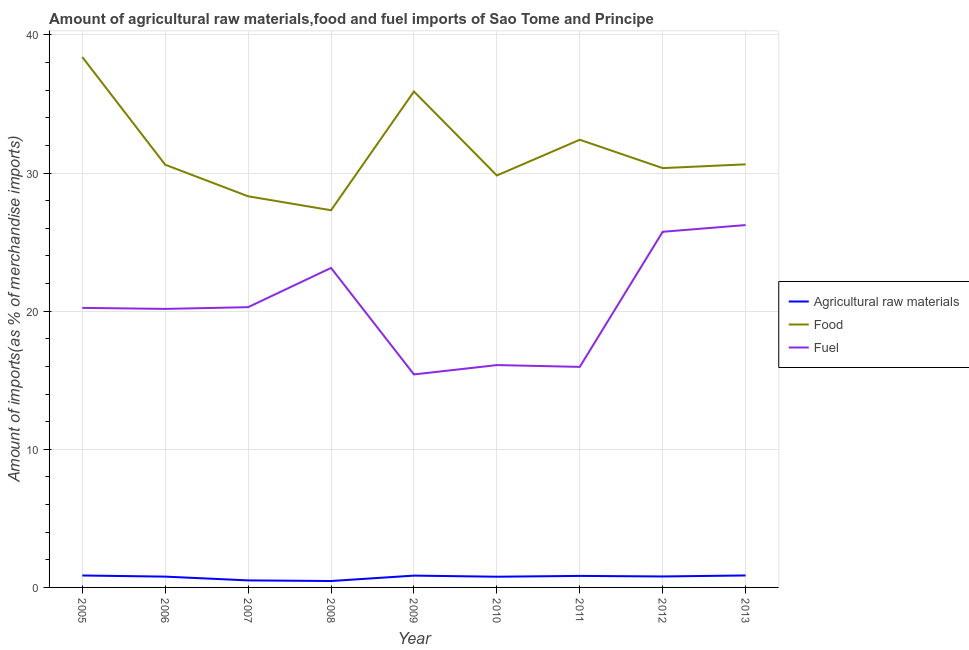Does the line corresponding to percentage of raw materials imports intersect with the line corresponding to percentage of fuel imports?
Your answer should be very brief. No. What is the percentage of raw materials imports in 2011?
Your answer should be compact. 0.83. Across all years, what is the maximum percentage of raw materials imports?
Make the answer very short. 0.87. Across all years, what is the minimum percentage of fuel imports?
Give a very brief answer. 15.42. In which year was the percentage of raw materials imports maximum?
Your answer should be compact. 2013. What is the total percentage of raw materials imports in the graph?
Make the answer very short. 6.74. What is the difference between the percentage of food imports in 2009 and that in 2013?
Provide a short and direct response. 5.28. What is the difference between the percentage of raw materials imports in 2010 and the percentage of food imports in 2011?
Offer a terse response. -31.64. What is the average percentage of fuel imports per year?
Your answer should be compact. 20.37. In the year 2007, what is the difference between the percentage of food imports and percentage of fuel imports?
Ensure brevity in your answer.  8.03. In how many years, is the percentage of raw materials imports greater than 38 %?
Offer a terse response. 0. What is the ratio of the percentage of raw materials imports in 2005 to that in 2009?
Offer a very short reply. 1.01. Is the difference between the percentage of food imports in 2005 and 2013 greater than the difference between the percentage of raw materials imports in 2005 and 2013?
Offer a terse response. Yes. What is the difference between the highest and the second highest percentage of food imports?
Your response must be concise. 2.5. What is the difference between the highest and the lowest percentage of food imports?
Offer a terse response. 11.09. Is the sum of the percentage of food imports in 2010 and 2011 greater than the maximum percentage of raw materials imports across all years?
Your answer should be compact. Yes. Does the percentage of raw materials imports monotonically increase over the years?
Offer a very short reply. No. Is the percentage of raw materials imports strictly less than the percentage of fuel imports over the years?
Your answer should be compact. Yes. Does the graph contain any zero values?
Provide a succinct answer. No. Does the graph contain grids?
Your response must be concise. Yes. How many legend labels are there?
Offer a terse response. 3. What is the title of the graph?
Give a very brief answer. Amount of agricultural raw materials,food and fuel imports of Sao Tome and Principe. What is the label or title of the X-axis?
Give a very brief answer. Year. What is the label or title of the Y-axis?
Your answer should be compact. Amount of imports(as % of merchandise imports). What is the Amount of imports(as % of merchandise imports) of Agricultural raw materials in 2005?
Provide a short and direct response. 0.86. What is the Amount of imports(as % of merchandise imports) of Food in 2005?
Ensure brevity in your answer.  38.4. What is the Amount of imports(as % of merchandise imports) in Fuel in 2005?
Offer a very short reply. 20.24. What is the Amount of imports(as % of merchandise imports) in Agricultural raw materials in 2006?
Provide a short and direct response. 0.78. What is the Amount of imports(as % of merchandise imports) of Food in 2006?
Keep it short and to the point. 30.6. What is the Amount of imports(as % of merchandise imports) in Fuel in 2006?
Your response must be concise. 20.17. What is the Amount of imports(as % of merchandise imports) in Agricultural raw materials in 2007?
Offer a very short reply. 0.51. What is the Amount of imports(as % of merchandise imports) in Food in 2007?
Your response must be concise. 28.32. What is the Amount of imports(as % of merchandise imports) in Fuel in 2007?
Keep it short and to the point. 20.29. What is the Amount of imports(as % of merchandise imports) of Agricultural raw materials in 2008?
Keep it short and to the point. 0.46. What is the Amount of imports(as % of merchandise imports) in Food in 2008?
Ensure brevity in your answer.  27.31. What is the Amount of imports(as % of merchandise imports) of Fuel in 2008?
Your answer should be compact. 23.13. What is the Amount of imports(as % of merchandise imports) in Agricultural raw materials in 2009?
Your answer should be very brief. 0.86. What is the Amount of imports(as % of merchandise imports) of Food in 2009?
Ensure brevity in your answer.  35.91. What is the Amount of imports(as % of merchandise imports) in Fuel in 2009?
Provide a succinct answer. 15.42. What is the Amount of imports(as % of merchandise imports) of Agricultural raw materials in 2010?
Provide a succinct answer. 0.77. What is the Amount of imports(as % of merchandise imports) in Food in 2010?
Provide a succinct answer. 29.83. What is the Amount of imports(as % of merchandise imports) in Fuel in 2010?
Keep it short and to the point. 16.1. What is the Amount of imports(as % of merchandise imports) of Agricultural raw materials in 2011?
Offer a terse response. 0.83. What is the Amount of imports(as % of merchandise imports) of Food in 2011?
Offer a terse response. 32.41. What is the Amount of imports(as % of merchandise imports) in Fuel in 2011?
Make the answer very short. 15.97. What is the Amount of imports(as % of merchandise imports) in Agricultural raw materials in 2012?
Give a very brief answer. 0.79. What is the Amount of imports(as % of merchandise imports) of Food in 2012?
Provide a succinct answer. 30.36. What is the Amount of imports(as % of merchandise imports) in Fuel in 2012?
Ensure brevity in your answer.  25.75. What is the Amount of imports(as % of merchandise imports) of Agricultural raw materials in 2013?
Keep it short and to the point. 0.87. What is the Amount of imports(as % of merchandise imports) of Food in 2013?
Your answer should be compact. 30.63. What is the Amount of imports(as % of merchandise imports) in Fuel in 2013?
Offer a very short reply. 26.24. Across all years, what is the maximum Amount of imports(as % of merchandise imports) in Agricultural raw materials?
Give a very brief answer. 0.87. Across all years, what is the maximum Amount of imports(as % of merchandise imports) in Food?
Offer a terse response. 38.4. Across all years, what is the maximum Amount of imports(as % of merchandise imports) in Fuel?
Your answer should be very brief. 26.24. Across all years, what is the minimum Amount of imports(as % of merchandise imports) in Agricultural raw materials?
Your response must be concise. 0.46. Across all years, what is the minimum Amount of imports(as % of merchandise imports) of Food?
Keep it short and to the point. 27.31. Across all years, what is the minimum Amount of imports(as % of merchandise imports) of Fuel?
Ensure brevity in your answer.  15.42. What is the total Amount of imports(as % of merchandise imports) of Agricultural raw materials in the graph?
Offer a terse response. 6.74. What is the total Amount of imports(as % of merchandise imports) in Food in the graph?
Your answer should be very brief. 283.77. What is the total Amount of imports(as % of merchandise imports) in Fuel in the graph?
Ensure brevity in your answer.  183.3. What is the difference between the Amount of imports(as % of merchandise imports) of Agricultural raw materials in 2005 and that in 2006?
Provide a short and direct response. 0.08. What is the difference between the Amount of imports(as % of merchandise imports) in Food in 2005 and that in 2006?
Keep it short and to the point. 7.8. What is the difference between the Amount of imports(as % of merchandise imports) in Fuel in 2005 and that in 2006?
Offer a terse response. 0.07. What is the difference between the Amount of imports(as % of merchandise imports) of Agricultural raw materials in 2005 and that in 2007?
Provide a short and direct response. 0.36. What is the difference between the Amount of imports(as % of merchandise imports) of Food in 2005 and that in 2007?
Offer a very short reply. 10.08. What is the difference between the Amount of imports(as % of merchandise imports) in Fuel in 2005 and that in 2007?
Provide a short and direct response. -0.05. What is the difference between the Amount of imports(as % of merchandise imports) of Agricultural raw materials in 2005 and that in 2008?
Make the answer very short. 0.4. What is the difference between the Amount of imports(as % of merchandise imports) of Food in 2005 and that in 2008?
Offer a very short reply. 11.09. What is the difference between the Amount of imports(as % of merchandise imports) in Fuel in 2005 and that in 2008?
Provide a short and direct response. -2.89. What is the difference between the Amount of imports(as % of merchandise imports) of Agricultural raw materials in 2005 and that in 2009?
Provide a short and direct response. 0.01. What is the difference between the Amount of imports(as % of merchandise imports) of Food in 2005 and that in 2009?
Offer a very short reply. 2.5. What is the difference between the Amount of imports(as % of merchandise imports) in Fuel in 2005 and that in 2009?
Your answer should be compact. 4.82. What is the difference between the Amount of imports(as % of merchandise imports) in Agricultural raw materials in 2005 and that in 2010?
Keep it short and to the point. 0.09. What is the difference between the Amount of imports(as % of merchandise imports) of Food in 2005 and that in 2010?
Offer a terse response. 8.58. What is the difference between the Amount of imports(as % of merchandise imports) in Fuel in 2005 and that in 2010?
Provide a succinct answer. 4.14. What is the difference between the Amount of imports(as % of merchandise imports) in Agricultural raw materials in 2005 and that in 2011?
Give a very brief answer. 0.03. What is the difference between the Amount of imports(as % of merchandise imports) of Food in 2005 and that in 2011?
Your answer should be compact. 5.99. What is the difference between the Amount of imports(as % of merchandise imports) of Fuel in 2005 and that in 2011?
Offer a very short reply. 4.27. What is the difference between the Amount of imports(as % of merchandise imports) in Agricultural raw materials in 2005 and that in 2012?
Ensure brevity in your answer.  0.07. What is the difference between the Amount of imports(as % of merchandise imports) of Food in 2005 and that in 2012?
Offer a very short reply. 8.04. What is the difference between the Amount of imports(as % of merchandise imports) in Fuel in 2005 and that in 2012?
Your answer should be compact. -5.51. What is the difference between the Amount of imports(as % of merchandise imports) in Agricultural raw materials in 2005 and that in 2013?
Keep it short and to the point. -0. What is the difference between the Amount of imports(as % of merchandise imports) of Food in 2005 and that in 2013?
Keep it short and to the point. 7.77. What is the difference between the Amount of imports(as % of merchandise imports) of Fuel in 2005 and that in 2013?
Your answer should be compact. -6. What is the difference between the Amount of imports(as % of merchandise imports) in Agricultural raw materials in 2006 and that in 2007?
Your answer should be very brief. 0.27. What is the difference between the Amount of imports(as % of merchandise imports) in Food in 2006 and that in 2007?
Your answer should be very brief. 2.29. What is the difference between the Amount of imports(as % of merchandise imports) of Fuel in 2006 and that in 2007?
Keep it short and to the point. -0.12. What is the difference between the Amount of imports(as % of merchandise imports) in Agricultural raw materials in 2006 and that in 2008?
Provide a short and direct response. 0.32. What is the difference between the Amount of imports(as % of merchandise imports) of Food in 2006 and that in 2008?
Give a very brief answer. 3.3. What is the difference between the Amount of imports(as % of merchandise imports) in Fuel in 2006 and that in 2008?
Make the answer very short. -2.97. What is the difference between the Amount of imports(as % of merchandise imports) in Agricultural raw materials in 2006 and that in 2009?
Your response must be concise. -0.07. What is the difference between the Amount of imports(as % of merchandise imports) in Food in 2006 and that in 2009?
Provide a succinct answer. -5.3. What is the difference between the Amount of imports(as % of merchandise imports) in Fuel in 2006 and that in 2009?
Keep it short and to the point. 4.74. What is the difference between the Amount of imports(as % of merchandise imports) in Agricultural raw materials in 2006 and that in 2010?
Your response must be concise. 0.01. What is the difference between the Amount of imports(as % of merchandise imports) of Food in 2006 and that in 2010?
Make the answer very short. 0.78. What is the difference between the Amount of imports(as % of merchandise imports) in Fuel in 2006 and that in 2010?
Make the answer very short. 4.07. What is the difference between the Amount of imports(as % of merchandise imports) in Agricultural raw materials in 2006 and that in 2011?
Offer a terse response. -0.05. What is the difference between the Amount of imports(as % of merchandise imports) in Food in 2006 and that in 2011?
Offer a very short reply. -1.81. What is the difference between the Amount of imports(as % of merchandise imports) of Fuel in 2006 and that in 2011?
Provide a short and direct response. 4.2. What is the difference between the Amount of imports(as % of merchandise imports) in Agricultural raw materials in 2006 and that in 2012?
Ensure brevity in your answer.  -0.01. What is the difference between the Amount of imports(as % of merchandise imports) in Food in 2006 and that in 2012?
Provide a short and direct response. 0.24. What is the difference between the Amount of imports(as % of merchandise imports) of Fuel in 2006 and that in 2012?
Offer a terse response. -5.58. What is the difference between the Amount of imports(as % of merchandise imports) in Agricultural raw materials in 2006 and that in 2013?
Your answer should be compact. -0.08. What is the difference between the Amount of imports(as % of merchandise imports) of Food in 2006 and that in 2013?
Your answer should be very brief. -0.03. What is the difference between the Amount of imports(as % of merchandise imports) in Fuel in 2006 and that in 2013?
Offer a very short reply. -6.07. What is the difference between the Amount of imports(as % of merchandise imports) of Agricultural raw materials in 2007 and that in 2008?
Give a very brief answer. 0.05. What is the difference between the Amount of imports(as % of merchandise imports) of Food in 2007 and that in 2008?
Keep it short and to the point. 1.01. What is the difference between the Amount of imports(as % of merchandise imports) of Fuel in 2007 and that in 2008?
Keep it short and to the point. -2.84. What is the difference between the Amount of imports(as % of merchandise imports) in Agricultural raw materials in 2007 and that in 2009?
Your answer should be very brief. -0.35. What is the difference between the Amount of imports(as % of merchandise imports) of Food in 2007 and that in 2009?
Offer a terse response. -7.59. What is the difference between the Amount of imports(as % of merchandise imports) of Fuel in 2007 and that in 2009?
Give a very brief answer. 4.87. What is the difference between the Amount of imports(as % of merchandise imports) of Agricultural raw materials in 2007 and that in 2010?
Give a very brief answer. -0.27. What is the difference between the Amount of imports(as % of merchandise imports) in Food in 2007 and that in 2010?
Keep it short and to the point. -1.51. What is the difference between the Amount of imports(as % of merchandise imports) of Fuel in 2007 and that in 2010?
Give a very brief answer. 4.19. What is the difference between the Amount of imports(as % of merchandise imports) in Agricultural raw materials in 2007 and that in 2011?
Offer a terse response. -0.32. What is the difference between the Amount of imports(as % of merchandise imports) of Food in 2007 and that in 2011?
Offer a terse response. -4.09. What is the difference between the Amount of imports(as % of merchandise imports) of Fuel in 2007 and that in 2011?
Your answer should be compact. 4.32. What is the difference between the Amount of imports(as % of merchandise imports) in Agricultural raw materials in 2007 and that in 2012?
Your answer should be compact. -0.28. What is the difference between the Amount of imports(as % of merchandise imports) in Food in 2007 and that in 2012?
Make the answer very short. -2.04. What is the difference between the Amount of imports(as % of merchandise imports) of Fuel in 2007 and that in 2012?
Offer a very short reply. -5.46. What is the difference between the Amount of imports(as % of merchandise imports) of Agricultural raw materials in 2007 and that in 2013?
Your response must be concise. -0.36. What is the difference between the Amount of imports(as % of merchandise imports) of Food in 2007 and that in 2013?
Provide a short and direct response. -2.31. What is the difference between the Amount of imports(as % of merchandise imports) of Fuel in 2007 and that in 2013?
Ensure brevity in your answer.  -5.94. What is the difference between the Amount of imports(as % of merchandise imports) of Agricultural raw materials in 2008 and that in 2009?
Keep it short and to the point. -0.39. What is the difference between the Amount of imports(as % of merchandise imports) of Food in 2008 and that in 2009?
Offer a terse response. -8.6. What is the difference between the Amount of imports(as % of merchandise imports) of Fuel in 2008 and that in 2009?
Offer a very short reply. 7.71. What is the difference between the Amount of imports(as % of merchandise imports) of Agricultural raw materials in 2008 and that in 2010?
Offer a very short reply. -0.31. What is the difference between the Amount of imports(as % of merchandise imports) in Food in 2008 and that in 2010?
Provide a short and direct response. -2.52. What is the difference between the Amount of imports(as % of merchandise imports) in Fuel in 2008 and that in 2010?
Keep it short and to the point. 7.03. What is the difference between the Amount of imports(as % of merchandise imports) of Agricultural raw materials in 2008 and that in 2011?
Give a very brief answer. -0.37. What is the difference between the Amount of imports(as % of merchandise imports) of Food in 2008 and that in 2011?
Offer a terse response. -5.1. What is the difference between the Amount of imports(as % of merchandise imports) of Fuel in 2008 and that in 2011?
Offer a very short reply. 7.16. What is the difference between the Amount of imports(as % of merchandise imports) of Agricultural raw materials in 2008 and that in 2012?
Provide a short and direct response. -0.33. What is the difference between the Amount of imports(as % of merchandise imports) of Food in 2008 and that in 2012?
Make the answer very short. -3.05. What is the difference between the Amount of imports(as % of merchandise imports) of Fuel in 2008 and that in 2012?
Your answer should be very brief. -2.62. What is the difference between the Amount of imports(as % of merchandise imports) in Agricultural raw materials in 2008 and that in 2013?
Offer a very short reply. -0.4. What is the difference between the Amount of imports(as % of merchandise imports) of Food in 2008 and that in 2013?
Your answer should be compact. -3.32. What is the difference between the Amount of imports(as % of merchandise imports) of Fuel in 2008 and that in 2013?
Provide a succinct answer. -3.1. What is the difference between the Amount of imports(as % of merchandise imports) in Agricultural raw materials in 2009 and that in 2010?
Make the answer very short. 0.08. What is the difference between the Amount of imports(as % of merchandise imports) in Food in 2009 and that in 2010?
Your answer should be very brief. 6.08. What is the difference between the Amount of imports(as % of merchandise imports) of Fuel in 2009 and that in 2010?
Offer a very short reply. -0.68. What is the difference between the Amount of imports(as % of merchandise imports) in Agricultural raw materials in 2009 and that in 2011?
Ensure brevity in your answer.  0.02. What is the difference between the Amount of imports(as % of merchandise imports) in Food in 2009 and that in 2011?
Provide a succinct answer. 3.49. What is the difference between the Amount of imports(as % of merchandise imports) in Fuel in 2009 and that in 2011?
Keep it short and to the point. -0.55. What is the difference between the Amount of imports(as % of merchandise imports) of Agricultural raw materials in 2009 and that in 2012?
Your answer should be very brief. 0.06. What is the difference between the Amount of imports(as % of merchandise imports) of Food in 2009 and that in 2012?
Your answer should be compact. 5.55. What is the difference between the Amount of imports(as % of merchandise imports) of Fuel in 2009 and that in 2012?
Make the answer very short. -10.33. What is the difference between the Amount of imports(as % of merchandise imports) of Agricultural raw materials in 2009 and that in 2013?
Offer a very short reply. -0.01. What is the difference between the Amount of imports(as % of merchandise imports) in Food in 2009 and that in 2013?
Give a very brief answer. 5.28. What is the difference between the Amount of imports(as % of merchandise imports) in Fuel in 2009 and that in 2013?
Ensure brevity in your answer.  -10.81. What is the difference between the Amount of imports(as % of merchandise imports) in Agricultural raw materials in 2010 and that in 2011?
Give a very brief answer. -0.06. What is the difference between the Amount of imports(as % of merchandise imports) of Food in 2010 and that in 2011?
Your response must be concise. -2.59. What is the difference between the Amount of imports(as % of merchandise imports) of Fuel in 2010 and that in 2011?
Your response must be concise. 0.13. What is the difference between the Amount of imports(as % of merchandise imports) of Agricultural raw materials in 2010 and that in 2012?
Provide a short and direct response. -0.02. What is the difference between the Amount of imports(as % of merchandise imports) of Food in 2010 and that in 2012?
Offer a terse response. -0.53. What is the difference between the Amount of imports(as % of merchandise imports) of Fuel in 2010 and that in 2012?
Your answer should be very brief. -9.65. What is the difference between the Amount of imports(as % of merchandise imports) of Agricultural raw materials in 2010 and that in 2013?
Make the answer very short. -0.09. What is the difference between the Amount of imports(as % of merchandise imports) of Food in 2010 and that in 2013?
Make the answer very short. -0.81. What is the difference between the Amount of imports(as % of merchandise imports) of Fuel in 2010 and that in 2013?
Your answer should be very brief. -10.14. What is the difference between the Amount of imports(as % of merchandise imports) of Agricultural raw materials in 2011 and that in 2012?
Offer a terse response. 0.04. What is the difference between the Amount of imports(as % of merchandise imports) in Food in 2011 and that in 2012?
Provide a short and direct response. 2.05. What is the difference between the Amount of imports(as % of merchandise imports) of Fuel in 2011 and that in 2012?
Your answer should be compact. -9.78. What is the difference between the Amount of imports(as % of merchandise imports) of Agricultural raw materials in 2011 and that in 2013?
Give a very brief answer. -0.03. What is the difference between the Amount of imports(as % of merchandise imports) in Food in 2011 and that in 2013?
Keep it short and to the point. 1.78. What is the difference between the Amount of imports(as % of merchandise imports) in Fuel in 2011 and that in 2013?
Your answer should be compact. -10.27. What is the difference between the Amount of imports(as % of merchandise imports) in Agricultural raw materials in 2012 and that in 2013?
Your response must be concise. -0.07. What is the difference between the Amount of imports(as % of merchandise imports) of Food in 2012 and that in 2013?
Provide a succinct answer. -0.27. What is the difference between the Amount of imports(as % of merchandise imports) in Fuel in 2012 and that in 2013?
Provide a succinct answer. -0.49. What is the difference between the Amount of imports(as % of merchandise imports) in Agricultural raw materials in 2005 and the Amount of imports(as % of merchandise imports) in Food in 2006?
Your response must be concise. -29.74. What is the difference between the Amount of imports(as % of merchandise imports) in Agricultural raw materials in 2005 and the Amount of imports(as % of merchandise imports) in Fuel in 2006?
Provide a succinct answer. -19.3. What is the difference between the Amount of imports(as % of merchandise imports) in Food in 2005 and the Amount of imports(as % of merchandise imports) in Fuel in 2006?
Provide a succinct answer. 18.24. What is the difference between the Amount of imports(as % of merchandise imports) of Agricultural raw materials in 2005 and the Amount of imports(as % of merchandise imports) of Food in 2007?
Your response must be concise. -27.45. What is the difference between the Amount of imports(as % of merchandise imports) of Agricultural raw materials in 2005 and the Amount of imports(as % of merchandise imports) of Fuel in 2007?
Give a very brief answer. -19.43. What is the difference between the Amount of imports(as % of merchandise imports) of Food in 2005 and the Amount of imports(as % of merchandise imports) of Fuel in 2007?
Offer a terse response. 18.11. What is the difference between the Amount of imports(as % of merchandise imports) in Agricultural raw materials in 2005 and the Amount of imports(as % of merchandise imports) in Food in 2008?
Keep it short and to the point. -26.44. What is the difference between the Amount of imports(as % of merchandise imports) in Agricultural raw materials in 2005 and the Amount of imports(as % of merchandise imports) in Fuel in 2008?
Your response must be concise. -22.27. What is the difference between the Amount of imports(as % of merchandise imports) of Food in 2005 and the Amount of imports(as % of merchandise imports) of Fuel in 2008?
Keep it short and to the point. 15.27. What is the difference between the Amount of imports(as % of merchandise imports) of Agricultural raw materials in 2005 and the Amount of imports(as % of merchandise imports) of Food in 2009?
Give a very brief answer. -35.04. What is the difference between the Amount of imports(as % of merchandise imports) in Agricultural raw materials in 2005 and the Amount of imports(as % of merchandise imports) in Fuel in 2009?
Provide a succinct answer. -14.56. What is the difference between the Amount of imports(as % of merchandise imports) of Food in 2005 and the Amount of imports(as % of merchandise imports) of Fuel in 2009?
Give a very brief answer. 22.98. What is the difference between the Amount of imports(as % of merchandise imports) in Agricultural raw materials in 2005 and the Amount of imports(as % of merchandise imports) in Food in 2010?
Your response must be concise. -28.96. What is the difference between the Amount of imports(as % of merchandise imports) in Agricultural raw materials in 2005 and the Amount of imports(as % of merchandise imports) in Fuel in 2010?
Give a very brief answer. -15.23. What is the difference between the Amount of imports(as % of merchandise imports) in Food in 2005 and the Amount of imports(as % of merchandise imports) in Fuel in 2010?
Keep it short and to the point. 22.3. What is the difference between the Amount of imports(as % of merchandise imports) in Agricultural raw materials in 2005 and the Amount of imports(as % of merchandise imports) in Food in 2011?
Your answer should be compact. -31.55. What is the difference between the Amount of imports(as % of merchandise imports) of Agricultural raw materials in 2005 and the Amount of imports(as % of merchandise imports) of Fuel in 2011?
Provide a succinct answer. -15.1. What is the difference between the Amount of imports(as % of merchandise imports) in Food in 2005 and the Amount of imports(as % of merchandise imports) in Fuel in 2011?
Make the answer very short. 22.43. What is the difference between the Amount of imports(as % of merchandise imports) in Agricultural raw materials in 2005 and the Amount of imports(as % of merchandise imports) in Food in 2012?
Your response must be concise. -29.5. What is the difference between the Amount of imports(as % of merchandise imports) in Agricultural raw materials in 2005 and the Amount of imports(as % of merchandise imports) in Fuel in 2012?
Make the answer very short. -24.88. What is the difference between the Amount of imports(as % of merchandise imports) of Food in 2005 and the Amount of imports(as % of merchandise imports) of Fuel in 2012?
Your answer should be very brief. 12.65. What is the difference between the Amount of imports(as % of merchandise imports) in Agricultural raw materials in 2005 and the Amount of imports(as % of merchandise imports) in Food in 2013?
Provide a succinct answer. -29.77. What is the difference between the Amount of imports(as % of merchandise imports) in Agricultural raw materials in 2005 and the Amount of imports(as % of merchandise imports) in Fuel in 2013?
Ensure brevity in your answer.  -25.37. What is the difference between the Amount of imports(as % of merchandise imports) of Food in 2005 and the Amount of imports(as % of merchandise imports) of Fuel in 2013?
Ensure brevity in your answer.  12.17. What is the difference between the Amount of imports(as % of merchandise imports) of Agricultural raw materials in 2006 and the Amount of imports(as % of merchandise imports) of Food in 2007?
Your answer should be very brief. -27.54. What is the difference between the Amount of imports(as % of merchandise imports) in Agricultural raw materials in 2006 and the Amount of imports(as % of merchandise imports) in Fuel in 2007?
Ensure brevity in your answer.  -19.51. What is the difference between the Amount of imports(as % of merchandise imports) in Food in 2006 and the Amount of imports(as % of merchandise imports) in Fuel in 2007?
Offer a terse response. 10.31. What is the difference between the Amount of imports(as % of merchandise imports) in Agricultural raw materials in 2006 and the Amount of imports(as % of merchandise imports) in Food in 2008?
Offer a very short reply. -26.53. What is the difference between the Amount of imports(as % of merchandise imports) of Agricultural raw materials in 2006 and the Amount of imports(as % of merchandise imports) of Fuel in 2008?
Your answer should be very brief. -22.35. What is the difference between the Amount of imports(as % of merchandise imports) of Food in 2006 and the Amount of imports(as % of merchandise imports) of Fuel in 2008?
Offer a terse response. 7.47. What is the difference between the Amount of imports(as % of merchandise imports) of Agricultural raw materials in 2006 and the Amount of imports(as % of merchandise imports) of Food in 2009?
Provide a short and direct response. -35.13. What is the difference between the Amount of imports(as % of merchandise imports) in Agricultural raw materials in 2006 and the Amount of imports(as % of merchandise imports) in Fuel in 2009?
Give a very brief answer. -14.64. What is the difference between the Amount of imports(as % of merchandise imports) of Food in 2006 and the Amount of imports(as % of merchandise imports) of Fuel in 2009?
Your answer should be compact. 15.18. What is the difference between the Amount of imports(as % of merchandise imports) in Agricultural raw materials in 2006 and the Amount of imports(as % of merchandise imports) in Food in 2010?
Offer a very short reply. -29.04. What is the difference between the Amount of imports(as % of merchandise imports) in Agricultural raw materials in 2006 and the Amount of imports(as % of merchandise imports) in Fuel in 2010?
Your answer should be very brief. -15.32. What is the difference between the Amount of imports(as % of merchandise imports) of Food in 2006 and the Amount of imports(as % of merchandise imports) of Fuel in 2010?
Provide a succinct answer. 14.51. What is the difference between the Amount of imports(as % of merchandise imports) of Agricultural raw materials in 2006 and the Amount of imports(as % of merchandise imports) of Food in 2011?
Give a very brief answer. -31.63. What is the difference between the Amount of imports(as % of merchandise imports) in Agricultural raw materials in 2006 and the Amount of imports(as % of merchandise imports) in Fuel in 2011?
Offer a very short reply. -15.19. What is the difference between the Amount of imports(as % of merchandise imports) of Food in 2006 and the Amount of imports(as % of merchandise imports) of Fuel in 2011?
Your response must be concise. 14.64. What is the difference between the Amount of imports(as % of merchandise imports) in Agricultural raw materials in 2006 and the Amount of imports(as % of merchandise imports) in Food in 2012?
Provide a succinct answer. -29.58. What is the difference between the Amount of imports(as % of merchandise imports) of Agricultural raw materials in 2006 and the Amount of imports(as % of merchandise imports) of Fuel in 2012?
Your response must be concise. -24.97. What is the difference between the Amount of imports(as % of merchandise imports) in Food in 2006 and the Amount of imports(as % of merchandise imports) in Fuel in 2012?
Ensure brevity in your answer.  4.86. What is the difference between the Amount of imports(as % of merchandise imports) in Agricultural raw materials in 2006 and the Amount of imports(as % of merchandise imports) in Food in 2013?
Provide a succinct answer. -29.85. What is the difference between the Amount of imports(as % of merchandise imports) in Agricultural raw materials in 2006 and the Amount of imports(as % of merchandise imports) in Fuel in 2013?
Ensure brevity in your answer.  -25.45. What is the difference between the Amount of imports(as % of merchandise imports) in Food in 2006 and the Amount of imports(as % of merchandise imports) in Fuel in 2013?
Your answer should be compact. 4.37. What is the difference between the Amount of imports(as % of merchandise imports) in Agricultural raw materials in 2007 and the Amount of imports(as % of merchandise imports) in Food in 2008?
Keep it short and to the point. -26.8. What is the difference between the Amount of imports(as % of merchandise imports) of Agricultural raw materials in 2007 and the Amount of imports(as % of merchandise imports) of Fuel in 2008?
Provide a short and direct response. -22.62. What is the difference between the Amount of imports(as % of merchandise imports) in Food in 2007 and the Amount of imports(as % of merchandise imports) in Fuel in 2008?
Keep it short and to the point. 5.19. What is the difference between the Amount of imports(as % of merchandise imports) of Agricultural raw materials in 2007 and the Amount of imports(as % of merchandise imports) of Food in 2009?
Keep it short and to the point. -35.4. What is the difference between the Amount of imports(as % of merchandise imports) in Agricultural raw materials in 2007 and the Amount of imports(as % of merchandise imports) in Fuel in 2009?
Offer a very short reply. -14.91. What is the difference between the Amount of imports(as % of merchandise imports) of Food in 2007 and the Amount of imports(as % of merchandise imports) of Fuel in 2009?
Offer a terse response. 12.9. What is the difference between the Amount of imports(as % of merchandise imports) of Agricultural raw materials in 2007 and the Amount of imports(as % of merchandise imports) of Food in 2010?
Provide a succinct answer. -29.32. What is the difference between the Amount of imports(as % of merchandise imports) in Agricultural raw materials in 2007 and the Amount of imports(as % of merchandise imports) in Fuel in 2010?
Make the answer very short. -15.59. What is the difference between the Amount of imports(as % of merchandise imports) of Food in 2007 and the Amount of imports(as % of merchandise imports) of Fuel in 2010?
Make the answer very short. 12.22. What is the difference between the Amount of imports(as % of merchandise imports) in Agricultural raw materials in 2007 and the Amount of imports(as % of merchandise imports) in Food in 2011?
Your response must be concise. -31.9. What is the difference between the Amount of imports(as % of merchandise imports) in Agricultural raw materials in 2007 and the Amount of imports(as % of merchandise imports) in Fuel in 2011?
Ensure brevity in your answer.  -15.46. What is the difference between the Amount of imports(as % of merchandise imports) of Food in 2007 and the Amount of imports(as % of merchandise imports) of Fuel in 2011?
Make the answer very short. 12.35. What is the difference between the Amount of imports(as % of merchandise imports) in Agricultural raw materials in 2007 and the Amount of imports(as % of merchandise imports) in Food in 2012?
Make the answer very short. -29.85. What is the difference between the Amount of imports(as % of merchandise imports) of Agricultural raw materials in 2007 and the Amount of imports(as % of merchandise imports) of Fuel in 2012?
Your response must be concise. -25.24. What is the difference between the Amount of imports(as % of merchandise imports) in Food in 2007 and the Amount of imports(as % of merchandise imports) in Fuel in 2012?
Your answer should be very brief. 2.57. What is the difference between the Amount of imports(as % of merchandise imports) in Agricultural raw materials in 2007 and the Amount of imports(as % of merchandise imports) in Food in 2013?
Your answer should be very brief. -30.12. What is the difference between the Amount of imports(as % of merchandise imports) of Agricultural raw materials in 2007 and the Amount of imports(as % of merchandise imports) of Fuel in 2013?
Make the answer very short. -25.73. What is the difference between the Amount of imports(as % of merchandise imports) of Food in 2007 and the Amount of imports(as % of merchandise imports) of Fuel in 2013?
Make the answer very short. 2.08. What is the difference between the Amount of imports(as % of merchandise imports) in Agricultural raw materials in 2008 and the Amount of imports(as % of merchandise imports) in Food in 2009?
Ensure brevity in your answer.  -35.44. What is the difference between the Amount of imports(as % of merchandise imports) of Agricultural raw materials in 2008 and the Amount of imports(as % of merchandise imports) of Fuel in 2009?
Your answer should be compact. -14.96. What is the difference between the Amount of imports(as % of merchandise imports) of Food in 2008 and the Amount of imports(as % of merchandise imports) of Fuel in 2009?
Your answer should be compact. 11.89. What is the difference between the Amount of imports(as % of merchandise imports) in Agricultural raw materials in 2008 and the Amount of imports(as % of merchandise imports) in Food in 2010?
Ensure brevity in your answer.  -29.36. What is the difference between the Amount of imports(as % of merchandise imports) of Agricultural raw materials in 2008 and the Amount of imports(as % of merchandise imports) of Fuel in 2010?
Your response must be concise. -15.63. What is the difference between the Amount of imports(as % of merchandise imports) of Food in 2008 and the Amount of imports(as % of merchandise imports) of Fuel in 2010?
Make the answer very short. 11.21. What is the difference between the Amount of imports(as % of merchandise imports) in Agricultural raw materials in 2008 and the Amount of imports(as % of merchandise imports) in Food in 2011?
Your answer should be compact. -31.95. What is the difference between the Amount of imports(as % of merchandise imports) of Agricultural raw materials in 2008 and the Amount of imports(as % of merchandise imports) of Fuel in 2011?
Make the answer very short. -15.5. What is the difference between the Amount of imports(as % of merchandise imports) of Food in 2008 and the Amount of imports(as % of merchandise imports) of Fuel in 2011?
Provide a succinct answer. 11.34. What is the difference between the Amount of imports(as % of merchandise imports) of Agricultural raw materials in 2008 and the Amount of imports(as % of merchandise imports) of Food in 2012?
Offer a very short reply. -29.9. What is the difference between the Amount of imports(as % of merchandise imports) in Agricultural raw materials in 2008 and the Amount of imports(as % of merchandise imports) in Fuel in 2012?
Provide a short and direct response. -25.29. What is the difference between the Amount of imports(as % of merchandise imports) in Food in 2008 and the Amount of imports(as % of merchandise imports) in Fuel in 2012?
Give a very brief answer. 1.56. What is the difference between the Amount of imports(as % of merchandise imports) of Agricultural raw materials in 2008 and the Amount of imports(as % of merchandise imports) of Food in 2013?
Your response must be concise. -30.17. What is the difference between the Amount of imports(as % of merchandise imports) in Agricultural raw materials in 2008 and the Amount of imports(as % of merchandise imports) in Fuel in 2013?
Your response must be concise. -25.77. What is the difference between the Amount of imports(as % of merchandise imports) of Food in 2008 and the Amount of imports(as % of merchandise imports) of Fuel in 2013?
Make the answer very short. 1.07. What is the difference between the Amount of imports(as % of merchandise imports) of Agricultural raw materials in 2009 and the Amount of imports(as % of merchandise imports) of Food in 2010?
Keep it short and to the point. -28.97. What is the difference between the Amount of imports(as % of merchandise imports) in Agricultural raw materials in 2009 and the Amount of imports(as % of merchandise imports) in Fuel in 2010?
Your answer should be compact. -15.24. What is the difference between the Amount of imports(as % of merchandise imports) in Food in 2009 and the Amount of imports(as % of merchandise imports) in Fuel in 2010?
Provide a succinct answer. 19.81. What is the difference between the Amount of imports(as % of merchandise imports) in Agricultural raw materials in 2009 and the Amount of imports(as % of merchandise imports) in Food in 2011?
Ensure brevity in your answer.  -31.56. What is the difference between the Amount of imports(as % of merchandise imports) of Agricultural raw materials in 2009 and the Amount of imports(as % of merchandise imports) of Fuel in 2011?
Make the answer very short. -15.11. What is the difference between the Amount of imports(as % of merchandise imports) in Food in 2009 and the Amount of imports(as % of merchandise imports) in Fuel in 2011?
Give a very brief answer. 19.94. What is the difference between the Amount of imports(as % of merchandise imports) in Agricultural raw materials in 2009 and the Amount of imports(as % of merchandise imports) in Food in 2012?
Keep it short and to the point. -29.5. What is the difference between the Amount of imports(as % of merchandise imports) of Agricultural raw materials in 2009 and the Amount of imports(as % of merchandise imports) of Fuel in 2012?
Your answer should be very brief. -24.89. What is the difference between the Amount of imports(as % of merchandise imports) in Food in 2009 and the Amount of imports(as % of merchandise imports) in Fuel in 2012?
Your answer should be very brief. 10.16. What is the difference between the Amount of imports(as % of merchandise imports) in Agricultural raw materials in 2009 and the Amount of imports(as % of merchandise imports) in Food in 2013?
Ensure brevity in your answer.  -29.78. What is the difference between the Amount of imports(as % of merchandise imports) of Agricultural raw materials in 2009 and the Amount of imports(as % of merchandise imports) of Fuel in 2013?
Your answer should be very brief. -25.38. What is the difference between the Amount of imports(as % of merchandise imports) in Food in 2009 and the Amount of imports(as % of merchandise imports) in Fuel in 2013?
Your answer should be very brief. 9.67. What is the difference between the Amount of imports(as % of merchandise imports) in Agricultural raw materials in 2010 and the Amount of imports(as % of merchandise imports) in Food in 2011?
Make the answer very short. -31.64. What is the difference between the Amount of imports(as % of merchandise imports) of Agricultural raw materials in 2010 and the Amount of imports(as % of merchandise imports) of Fuel in 2011?
Offer a terse response. -15.19. What is the difference between the Amount of imports(as % of merchandise imports) in Food in 2010 and the Amount of imports(as % of merchandise imports) in Fuel in 2011?
Your answer should be very brief. 13.86. What is the difference between the Amount of imports(as % of merchandise imports) in Agricultural raw materials in 2010 and the Amount of imports(as % of merchandise imports) in Food in 2012?
Make the answer very short. -29.59. What is the difference between the Amount of imports(as % of merchandise imports) of Agricultural raw materials in 2010 and the Amount of imports(as % of merchandise imports) of Fuel in 2012?
Your response must be concise. -24.97. What is the difference between the Amount of imports(as % of merchandise imports) in Food in 2010 and the Amount of imports(as % of merchandise imports) in Fuel in 2012?
Offer a terse response. 4.08. What is the difference between the Amount of imports(as % of merchandise imports) in Agricultural raw materials in 2010 and the Amount of imports(as % of merchandise imports) in Food in 2013?
Provide a short and direct response. -29.86. What is the difference between the Amount of imports(as % of merchandise imports) in Agricultural raw materials in 2010 and the Amount of imports(as % of merchandise imports) in Fuel in 2013?
Provide a short and direct response. -25.46. What is the difference between the Amount of imports(as % of merchandise imports) in Food in 2010 and the Amount of imports(as % of merchandise imports) in Fuel in 2013?
Your response must be concise. 3.59. What is the difference between the Amount of imports(as % of merchandise imports) of Agricultural raw materials in 2011 and the Amount of imports(as % of merchandise imports) of Food in 2012?
Give a very brief answer. -29.53. What is the difference between the Amount of imports(as % of merchandise imports) of Agricultural raw materials in 2011 and the Amount of imports(as % of merchandise imports) of Fuel in 2012?
Your answer should be very brief. -24.92. What is the difference between the Amount of imports(as % of merchandise imports) of Food in 2011 and the Amount of imports(as % of merchandise imports) of Fuel in 2012?
Provide a short and direct response. 6.66. What is the difference between the Amount of imports(as % of merchandise imports) of Agricultural raw materials in 2011 and the Amount of imports(as % of merchandise imports) of Food in 2013?
Make the answer very short. -29.8. What is the difference between the Amount of imports(as % of merchandise imports) in Agricultural raw materials in 2011 and the Amount of imports(as % of merchandise imports) in Fuel in 2013?
Your answer should be compact. -25.4. What is the difference between the Amount of imports(as % of merchandise imports) in Food in 2011 and the Amount of imports(as % of merchandise imports) in Fuel in 2013?
Provide a succinct answer. 6.18. What is the difference between the Amount of imports(as % of merchandise imports) of Agricultural raw materials in 2012 and the Amount of imports(as % of merchandise imports) of Food in 2013?
Make the answer very short. -29.84. What is the difference between the Amount of imports(as % of merchandise imports) in Agricultural raw materials in 2012 and the Amount of imports(as % of merchandise imports) in Fuel in 2013?
Give a very brief answer. -25.44. What is the difference between the Amount of imports(as % of merchandise imports) of Food in 2012 and the Amount of imports(as % of merchandise imports) of Fuel in 2013?
Make the answer very short. 4.12. What is the average Amount of imports(as % of merchandise imports) of Agricultural raw materials per year?
Provide a succinct answer. 0.75. What is the average Amount of imports(as % of merchandise imports) in Food per year?
Offer a very short reply. 31.53. What is the average Amount of imports(as % of merchandise imports) in Fuel per year?
Make the answer very short. 20.37. In the year 2005, what is the difference between the Amount of imports(as % of merchandise imports) in Agricultural raw materials and Amount of imports(as % of merchandise imports) in Food?
Ensure brevity in your answer.  -37.54. In the year 2005, what is the difference between the Amount of imports(as % of merchandise imports) of Agricultural raw materials and Amount of imports(as % of merchandise imports) of Fuel?
Ensure brevity in your answer.  -19.38. In the year 2005, what is the difference between the Amount of imports(as % of merchandise imports) of Food and Amount of imports(as % of merchandise imports) of Fuel?
Make the answer very short. 18.16. In the year 2006, what is the difference between the Amount of imports(as % of merchandise imports) in Agricultural raw materials and Amount of imports(as % of merchandise imports) in Food?
Make the answer very short. -29.82. In the year 2006, what is the difference between the Amount of imports(as % of merchandise imports) in Agricultural raw materials and Amount of imports(as % of merchandise imports) in Fuel?
Give a very brief answer. -19.38. In the year 2006, what is the difference between the Amount of imports(as % of merchandise imports) in Food and Amount of imports(as % of merchandise imports) in Fuel?
Your response must be concise. 10.44. In the year 2007, what is the difference between the Amount of imports(as % of merchandise imports) of Agricultural raw materials and Amount of imports(as % of merchandise imports) of Food?
Ensure brevity in your answer.  -27.81. In the year 2007, what is the difference between the Amount of imports(as % of merchandise imports) of Agricultural raw materials and Amount of imports(as % of merchandise imports) of Fuel?
Provide a short and direct response. -19.78. In the year 2007, what is the difference between the Amount of imports(as % of merchandise imports) of Food and Amount of imports(as % of merchandise imports) of Fuel?
Make the answer very short. 8.03. In the year 2008, what is the difference between the Amount of imports(as % of merchandise imports) in Agricultural raw materials and Amount of imports(as % of merchandise imports) in Food?
Offer a very short reply. -26.84. In the year 2008, what is the difference between the Amount of imports(as % of merchandise imports) of Agricultural raw materials and Amount of imports(as % of merchandise imports) of Fuel?
Your response must be concise. -22.67. In the year 2008, what is the difference between the Amount of imports(as % of merchandise imports) of Food and Amount of imports(as % of merchandise imports) of Fuel?
Provide a short and direct response. 4.18. In the year 2009, what is the difference between the Amount of imports(as % of merchandise imports) in Agricultural raw materials and Amount of imports(as % of merchandise imports) in Food?
Your answer should be compact. -35.05. In the year 2009, what is the difference between the Amount of imports(as % of merchandise imports) in Agricultural raw materials and Amount of imports(as % of merchandise imports) in Fuel?
Keep it short and to the point. -14.57. In the year 2009, what is the difference between the Amount of imports(as % of merchandise imports) in Food and Amount of imports(as % of merchandise imports) in Fuel?
Ensure brevity in your answer.  20.49. In the year 2010, what is the difference between the Amount of imports(as % of merchandise imports) in Agricultural raw materials and Amount of imports(as % of merchandise imports) in Food?
Keep it short and to the point. -29.05. In the year 2010, what is the difference between the Amount of imports(as % of merchandise imports) in Agricultural raw materials and Amount of imports(as % of merchandise imports) in Fuel?
Offer a terse response. -15.32. In the year 2010, what is the difference between the Amount of imports(as % of merchandise imports) of Food and Amount of imports(as % of merchandise imports) of Fuel?
Offer a very short reply. 13.73. In the year 2011, what is the difference between the Amount of imports(as % of merchandise imports) in Agricultural raw materials and Amount of imports(as % of merchandise imports) in Food?
Provide a short and direct response. -31.58. In the year 2011, what is the difference between the Amount of imports(as % of merchandise imports) of Agricultural raw materials and Amount of imports(as % of merchandise imports) of Fuel?
Ensure brevity in your answer.  -15.13. In the year 2011, what is the difference between the Amount of imports(as % of merchandise imports) of Food and Amount of imports(as % of merchandise imports) of Fuel?
Your answer should be compact. 16.44. In the year 2012, what is the difference between the Amount of imports(as % of merchandise imports) in Agricultural raw materials and Amount of imports(as % of merchandise imports) in Food?
Your answer should be very brief. -29.57. In the year 2012, what is the difference between the Amount of imports(as % of merchandise imports) in Agricultural raw materials and Amount of imports(as % of merchandise imports) in Fuel?
Keep it short and to the point. -24.96. In the year 2012, what is the difference between the Amount of imports(as % of merchandise imports) in Food and Amount of imports(as % of merchandise imports) in Fuel?
Provide a short and direct response. 4.61. In the year 2013, what is the difference between the Amount of imports(as % of merchandise imports) in Agricultural raw materials and Amount of imports(as % of merchandise imports) in Food?
Your response must be concise. -29.77. In the year 2013, what is the difference between the Amount of imports(as % of merchandise imports) in Agricultural raw materials and Amount of imports(as % of merchandise imports) in Fuel?
Keep it short and to the point. -25.37. In the year 2013, what is the difference between the Amount of imports(as % of merchandise imports) in Food and Amount of imports(as % of merchandise imports) in Fuel?
Your response must be concise. 4.4. What is the ratio of the Amount of imports(as % of merchandise imports) of Agricultural raw materials in 2005 to that in 2006?
Your answer should be compact. 1.11. What is the ratio of the Amount of imports(as % of merchandise imports) in Food in 2005 to that in 2006?
Make the answer very short. 1.25. What is the ratio of the Amount of imports(as % of merchandise imports) in Fuel in 2005 to that in 2006?
Your answer should be compact. 1. What is the ratio of the Amount of imports(as % of merchandise imports) of Agricultural raw materials in 2005 to that in 2007?
Keep it short and to the point. 1.7. What is the ratio of the Amount of imports(as % of merchandise imports) of Food in 2005 to that in 2007?
Your response must be concise. 1.36. What is the ratio of the Amount of imports(as % of merchandise imports) of Fuel in 2005 to that in 2007?
Make the answer very short. 1. What is the ratio of the Amount of imports(as % of merchandise imports) in Agricultural raw materials in 2005 to that in 2008?
Provide a short and direct response. 1.86. What is the ratio of the Amount of imports(as % of merchandise imports) of Food in 2005 to that in 2008?
Provide a short and direct response. 1.41. What is the ratio of the Amount of imports(as % of merchandise imports) in Agricultural raw materials in 2005 to that in 2009?
Your response must be concise. 1.01. What is the ratio of the Amount of imports(as % of merchandise imports) in Food in 2005 to that in 2009?
Offer a terse response. 1.07. What is the ratio of the Amount of imports(as % of merchandise imports) in Fuel in 2005 to that in 2009?
Offer a terse response. 1.31. What is the ratio of the Amount of imports(as % of merchandise imports) in Agricultural raw materials in 2005 to that in 2010?
Make the answer very short. 1.12. What is the ratio of the Amount of imports(as % of merchandise imports) in Food in 2005 to that in 2010?
Provide a short and direct response. 1.29. What is the ratio of the Amount of imports(as % of merchandise imports) of Fuel in 2005 to that in 2010?
Give a very brief answer. 1.26. What is the ratio of the Amount of imports(as % of merchandise imports) in Agricultural raw materials in 2005 to that in 2011?
Make the answer very short. 1.04. What is the ratio of the Amount of imports(as % of merchandise imports) in Food in 2005 to that in 2011?
Ensure brevity in your answer.  1.18. What is the ratio of the Amount of imports(as % of merchandise imports) in Fuel in 2005 to that in 2011?
Ensure brevity in your answer.  1.27. What is the ratio of the Amount of imports(as % of merchandise imports) of Agricultural raw materials in 2005 to that in 2012?
Your answer should be very brief. 1.09. What is the ratio of the Amount of imports(as % of merchandise imports) of Food in 2005 to that in 2012?
Make the answer very short. 1.26. What is the ratio of the Amount of imports(as % of merchandise imports) in Fuel in 2005 to that in 2012?
Provide a short and direct response. 0.79. What is the ratio of the Amount of imports(as % of merchandise imports) in Agricultural raw materials in 2005 to that in 2013?
Ensure brevity in your answer.  1. What is the ratio of the Amount of imports(as % of merchandise imports) in Food in 2005 to that in 2013?
Offer a terse response. 1.25. What is the ratio of the Amount of imports(as % of merchandise imports) of Fuel in 2005 to that in 2013?
Make the answer very short. 0.77. What is the ratio of the Amount of imports(as % of merchandise imports) of Agricultural raw materials in 2006 to that in 2007?
Ensure brevity in your answer.  1.53. What is the ratio of the Amount of imports(as % of merchandise imports) in Food in 2006 to that in 2007?
Your answer should be very brief. 1.08. What is the ratio of the Amount of imports(as % of merchandise imports) of Fuel in 2006 to that in 2007?
Give a very brief answer. 0.99. What is the ratio of the Amount of imports(as % of merchandise imports) in Agricultural raw materials in 2006 to that in 2008?
Ensure brevity in your answer.  1.69. What is the ratio of the Amount of imports(as % of merchandise imports) of Food in 2006 to that in 2008?
Offer a very short reply. 1.12. What is the ratio of the Amount of imports(as % of merchandise imports) in Fuel in 2006 to that in 2008?
Ensure brevity in your answer.  0.87. What is the ratio of the Amount of imports(as % of merchandise imports) in Agricultural raw materials in 2006 to that in 2009?
Your answer should be very brief. 0.91. What is the ratio of the Amount of imports(as % of merchandise imports) in Food in 2006 to that in 2009?
Ensure brevity in your answer.  0.85. What is the ratio of the Amount of imports(as % of merchandise imports) in Fuel in 2006 to that in 2009?
Provide a short and direct response. 1.31. What is the ratio of the Amount of imports(as % of merchandise imports) in Agricultural raw materials in 2006 to that in 2010?
Make the answer very short. 1.01. What is the ratio of the Amount of imports(as % of merchandise imports) in Food in 2006 to that in 2010?
Give a very brief answer. 1.03. What is the ratio of the Amount of imports(as % of merchandise imports) in Fuel in 2006 to that in 2010?
Offer a terse response. 1.25. What is the ratio of the Amount of imports(as % of merchandise imports) in Agricultural raw materials in 2006 to that in 2011?
Ensure brevity in your answer.  0.94. What is the ratio of the Amount of imports(as % of merchandise imports) in Food in 2006 to that in 2011?
Offer a very short reply. 0.94. What is the ratio of the Amount of imports(as % of merchandise imports) of Fuel in 2006 to that in 2011?
Your response must be concise. 1.26. What is the ratio of the Amount of imports(as % of merchandise imports) in Agricultural raw materials in 2006 to that in 2012?
Provide a short and direct response. 0.99. What is the ratio of the Amount of imports(as % of merchandise imports) in Food in 2006 to that in 2012?
Your answer should be very brief. 1.01. What is the ratio of the Amount of imports(as % of merchandise imports) of Fuel in 2006 to that in 2012?
Your answer should be very brief. 0.78. What is the ratio of the Amount of imports(as % of merchandise imports) in Agricultural raw materials in 2006 to that in 2013?
Your response must be concise. 0.9. What is the ratio of the Amount of imports(as % of merchandise imports) of Food in 2006 to that in 2013?
Ensure brevity in your answer.  1. What is the ratio of the Amount of imports(as % of merchandise imports) in Fuel in 2006 to that in 2013?
Give a very brief answer. 0.77. What is the ratio of the Amount of imports(as % of merchandise imports) of Agricultural raw materials in 2007 to that in 2008?
Make the answer very short. 1.1. What is the ratio of the Amount of imports(as % of merchandise imports) in Fuel in 2007 to that in 2008?
Your response must be concise. 0.88. What is the ratio of the Amount of imports(as % of merchandise imports) of Agricultural raw materials in 2007 to that in 2009?
Ensure brevity in your answer.  0.6. What is the ratio of the Amount of imports(as % of merchandise imports) of Food in 2007 to that in 2009?
Offer a very short reply. 0.79. What is the ratio of the Amount of imports(as % of merchandise imports) of Fuel in 2007 to that in 2009?
Offer a very short reply. 1.32. What is the ratio of the Amount of imports(as % of merchandise imports) in Agricultural raw materials in 2007 to that in 2010?
Your answer should be very brief. 0.66. What is the ratio of the Amount of imports(as % of merchandise imports) of Food in 2007 to that in 2010?
Offer a terse response. 0.95. What is the ratio of the Amount of imports(as % of merchandise imports) in Fuel in 2007 to that in 2010?
Your response must be concise. 1.26. What is the ratio of the Amount of imports(as % of merchandise imports) of Agricultural raw materials in 2007 to that in 2011?
Give a very brief answer. 0.61. What is the ratio of the Amount of imports(as % of merchandise imports) in Food in 2007 to that in 2011?
Your answer should be very brief. 0.87. What is the ratio of the Amount of imports(as % of merchandise imports) in Fuel in 2007 to that in 2011?
Offer a terse response. 1.27. What is the ratio of the Amount of imports(as % of merchandise imports) in Agricultural raw materials in 2007 to that in 2012?
Your answer should be very brief. 0.64. What is the ratio of the Amount of imports(as % of merchandise imports) in Food in 2007 to that in 2012?
Give a very brief answer. 0.93. What is the ratio of the Amount of imports(as % of merchandise imports) in Fuel in 2007 to that in 2012?
Your response must be concise. 0.79. What is the ratio of the Amount of imports(as % of merchandise imports) of Agricultural raw materials in 2007 to that in 2013?
Keep it short and to the point. 0.59. What is the ratio of the Amount of imports(as % of merchandise imports) of Food in 2007 to that in 2013?
Give a very brief answer. 0.92. What is the ratio of the Amount of imports(as % of merchandise imports) of Fuel in 2007 to that in 2013?
Your response must be concise. 0.77. What is the ratio of the Amount of imports(as % of merchandise imports) of Agricultural raw materials in 2008 to that in 2009?
Your answer should be very brief. 0.54. What is the ratio of the Amount of imports(as % of merchandise imports) of Food in 2008 to that in 2009?
Keep it short and to the point. 0.76. What is the ratio of the Amount of imports(as % of merchandise imports) in Agricultural raw materials in 2008 to that in 2010?
Your answer should be very brief. 0.6. What is the ratio of the Amount of imports(as % of merchandise imports) in Food in 2008 to that in 2010?
Make the answer very short. 0.92. What is the ratio of the Amount of imports(as % of merchandise imports) in Fuel in 2008 to that in 2010?
Make the answer very short. 1.44. What is the ratio of the Amount of imports(as % of merchandise imports) of Agricultural raw materials in 2008 to that in 2011?
Your answer should be very brief. 0.56. What is the ratio of the Amount of imports(as % of merchandise imports) of Food in 2008 to that in 2011?
Provide a succinct answer. 0.84. What is the ratio of the Amount of imports(as % of merchandise imports) of Fuel in 2008 to that in 2011?
Your answer should be compact. 1.45. What is the ratio of the Amount of imports(as % of merchandise imports) in Agricultural raw materials in 2008 to that in 2012?
Make the answer very short. 0.58. What is the ratio of the Amount of imports(as % of merchandise imports) in Food in 2008 to that in 2012?
Make the answer very short. 0.9. What is the ratio of the Amount of imports(as % of merchandise imports) of Fuel in 2008 to that in 2012?
Keep it short and to the point. 0.9. What is the ratio of the Amount of imports(as % of merchandise imports) of Agricultural raw materials in 2008 to that in 2013?
Keep it short and to the point. 0.54. What is the ratio of the Amount of imports(as % of merchandise imports) of Food in 2008 to that in 2013?
Your answer should be very brief. 0.89. What is the ratio of the Amount of imports(as % of merchandise imports) of Fuel in 2008 to that in 2013?
Offer a terse response. 0.88. What is the ratio of the Amount of imports(as % of merchandise imports) of Agricultural raw materials in 2009 to that in 2010?
Offer a terse response. 1.1. What is the ratio of the Amount of imports(as % of merchandise imports) in Food in 2009 to that in 2010?
Provide a succinct answer. 1.2. What is the ratio of the Amount of imports(as % of merchandise imports) of Fuel in 2009 to that in 2010?
Give a very brief answer. 0.96. What is the ratio of the Amount of imports(as % of merchandise imports) of Agricultural raw materials in 2009 to that in 2011?
Provide a succinct answer. 1.03. What is the ratio of the Amount of imports(as % of merchandise imports) of Food in 2009 to that in 2011?
Make the answer very short. 1.11. What is the ratio of the Amount of imports(as % of merchandise imports) in Fuel in 2009 to that in 2011?
Give a very brief answer. 0.97. What is the ratio of the Amount of imports(as % of merchandise imports) of Agricultural raw materials in 2009 to that in 2012?
Your answer should be compact. 1.08. What is the ratio of the Amount of imports(as % of merchandise imports) in Food in 2009 to that in 2012?
Keep it short and to the point. 1.18. What is the ratio of the Amount of imports(as % of merchandise imports) of Fuel in 2009 to that in 2012?
Provide a short and direct response. 0.6. What is the ratio of the Amount of imports(as % of merchandise imports) of Agricultural raw materials in 2009 to that in 2013?
Offer a terse response. 0.99. What is the ratio of the Amount of imports(as % of merchandise imports) of Food in 2009 to that in 2013?
Provide a succinct answer. 1.17. What is the ratio of the Amount of imports(as % of merchandise imports) in Fuel in 2009 to that in 2013?
Your answer should be very brief. 0.59. What is the ratio of the Amount of imports(as % of merchandise imports) in Agricultural raw materials in 2010 to that in 2011?
Give a very brief answer. 0.93. What is the ratio of the Amount of imports(as % of merchandise imports) in Food in 2010 to that in 2011?
Your response must be concise. 0.92. What is the ratio of the Amount of imports(as % of merchandise imports) of Agricultural raw materials in 2010 to that in 2012?
Your answer should be compact. 0.98. What is the ratio of the Amount of imports(as % of merchandise imports) of Food in 2010 to that in 2012?
Make the answer very short. 0.98. What is the ratio of the Amount of imports(as % of merchandise imports) of Fuel in 2010 to that in 2012?
Offer a terse response. 0.63. What is the ratio of the Amount of imports(as % of merchandise imports) in Agricultural raw materials in 2010 to that in 2013?
Your answer should be very brief. 0.89. What is the ratio of the Amount of imports(as % of merchandise imports) of Food in 2010 to that in 2013?
Provide a short and direct response. 0.97. What is the ratio of the Amount of imports(as % of merchandise imports) in Fuel in 2010 to that in 2013?
Keep it short and to the point. 0.61. What is the ratio of the Amount of imports(as % of merchandise imports) of Agricultural raw materials in 2011 to that in 2012?
Offer a very short reply. 1.05. What is the ratio of the Amount of imports(as % of merchandise imports) in Food in 2011 to that in 2012?
Your answer should be very brief. 1.07. What is the ratio of the Amount of imports(as % of merchandise imports) of Fuel in 2011 to that in 2012?
Offer a terse response. 0.62. What is the ratio of the Amount of imports(as % of merchandise imports) in Agricultural raw materials in 2011 to that in 2013?
Your answer should be compact. 0.96. What is the ratio of the Amount of imports(as % of merchandise imports) in Food in 2011 to that in 2013?
Give a very brief answer. 1.06. What is the ratio of the Amount of imports(as % of merchandise imports) in Fuel in 2011 to that in 2013?
Provide a short and direct response. 0.61. What is the ratio of the Amount of imports(as % of merchandise imports) of Agricultural raw materials in 2012 to that in 2013?
Your response must be concise. 0.92. What is the ratio of the Amount of imports(as % of merchandise imports) in Food in 2012 to that in 2013?
Your response must be concise. 0.99. What is the ratio of the Amount of imports(as % of merchandise imports) of Fuel in 2012 to that in 2013?
Provide a succinct answer. 0.98. What is the difference between the highest and the second highest Amount of imports(as % of merchandise imports) in Agricultural raw materials?
Your answer should be very brief. 0. What is the difference between the highest and the second highest Amount of imports(as % of merchandise imports) of Food?
Provide a short and direct response. 2.5. What is the difference between the highest and the second highest Amount of imports(as % of merchandise imports) of Fuel?
Give a very brief answer. 0.49. What is the difference between the highest and the lowest Amount of imports(as % of merchandise imports) of Agricultural raw materials?
Ensure brevity in your answer.  0.4. What is the difference between the highest and the lowest Amount of imports(as % of merchandise imports) in Food?
Your answer should be compact. 11.09. What is the difference between the highest and the lowest Amount of imports(as % of merchandise imports) of Fuel?
Your response must be concise. 10.81. 